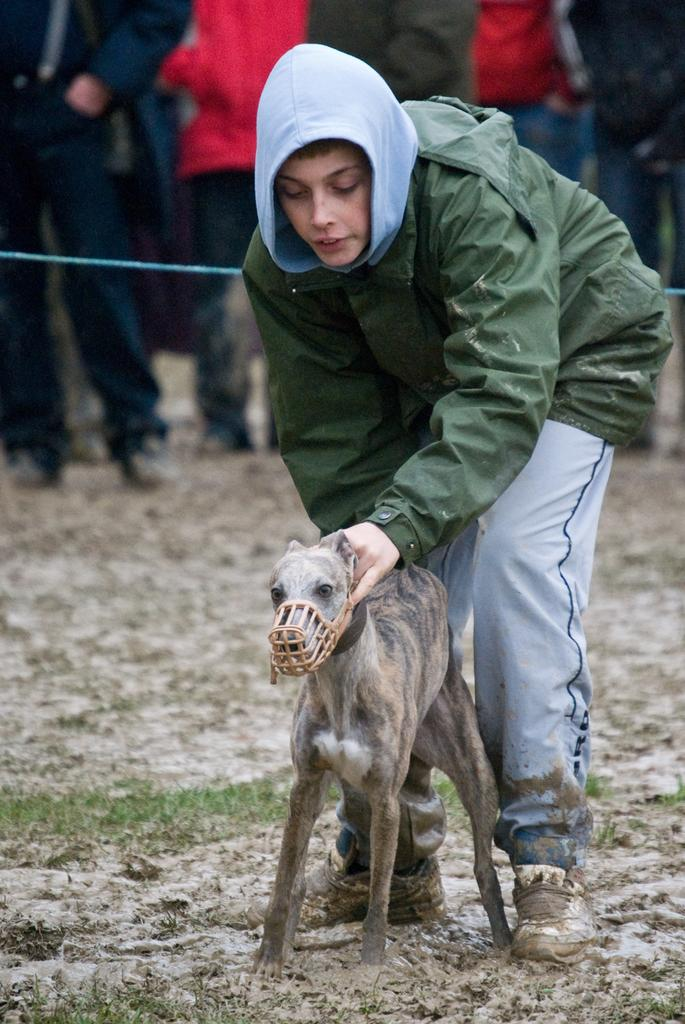Who is the main subject in the image? There is a man in the image. What is the man wearing? The man is wearing a rain jacket. What is the man doing in the image? The man is catching a dog. Are there any other people in the image? Yes, there are persons behind the man. What are the persons behind the man doing? The persons are watching the man and the dog. What type of butter can be seen in the frame of the image? There is no butter present in the image. Is the scene in the image characterized by harmony? The question of harmony is subjective and cannot be definitively answered based on the provided facts. However, the man is attempting to catch a dog, which may indicate some level of discord or challenge in the scene. 